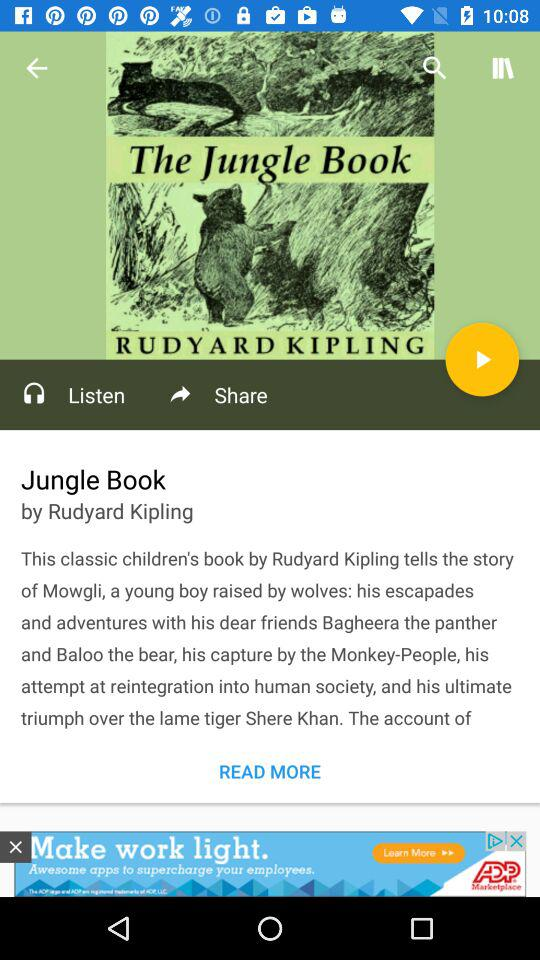Who is the writer of "The Jungle Book"? The writer is Rudyard Kipling. 